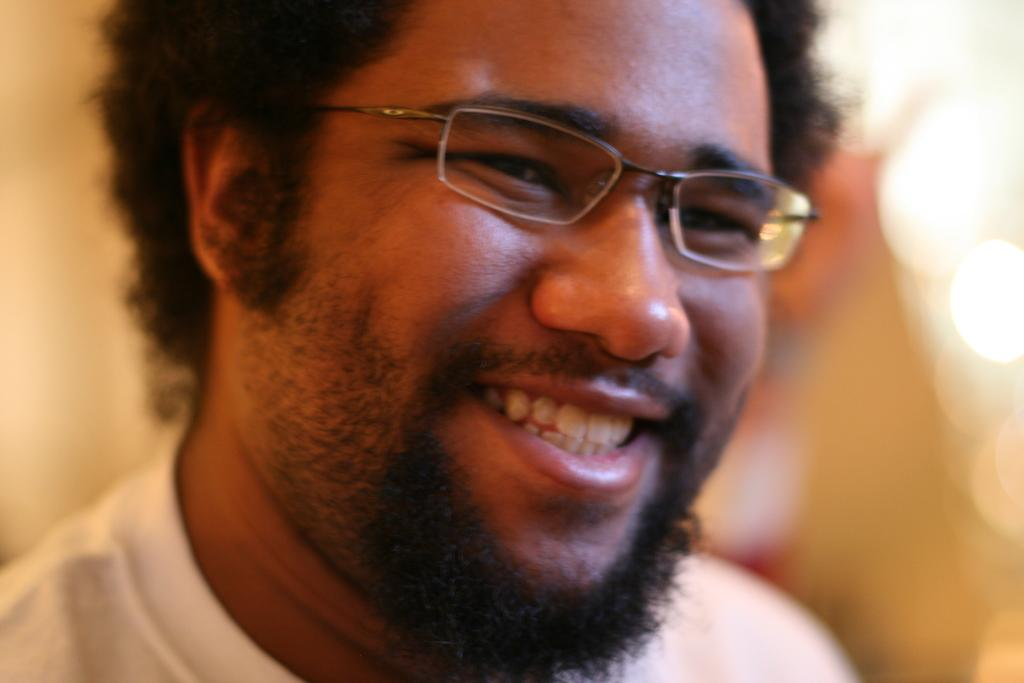Who is the main subject in the image? There is a man in the center of the image. What is the man wearing in the image? The man is wearing glasses in the image. Can you describe the background of the image? The background of the image is blurry. What type of bean is being used to clean the tin in the image? There is no bean or tin present in the image; it features a man wearing glasses in the center of the image with a blurry background. 